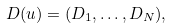<formula> <loc_0><loc_0><loc_500><loc_500>D ( u ) = ( D _ { 1 } , \dots , D _ { N } ) ,</formula> 